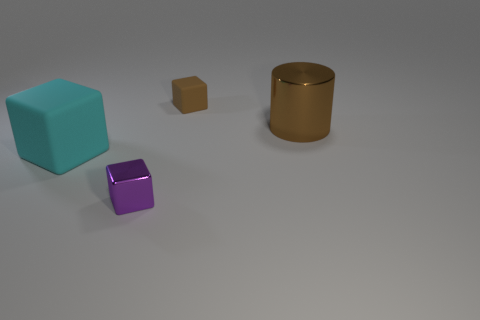What shape is the metal thing that is the same color as the tiny matte object?
Provide a succinct answer. Cylinder. Is the size of the brown metallic thing the same as the rubber thing that is behind the brown cylinder?
Your response must be concise. No. There is a block that is behind the tiny metal thing and in front of the brown rubber cube; what color is it?
Offer a terse response. Cyan. Is the number of brown matte cubes that are in front of the small purple thing greater than the number of purple objects that are behind the big metallic cylinder?
Your answer should be very brief. No. There is a cyan thing that is made of the same material as the small brown cube; what is its size?
Provide a succinct answer. Large. How many rubber things are in front of the tiny block that is in front of the brown cube?
Ensure brevity in your answer.  0. Is there another purple object of the same shape as the tiny purple metal object?
Keep it short and to the point. No. What is the color of the small cube that is behind the big cylinder that is in front of the brown rubber thing?
Provide a short and direct response. Brown. Are there more tiny brown blocks than small objects?
Provide a short and direct response. No. How many shiny objects are the same size as the brown cube?
Provide a short and direct response. 1. 